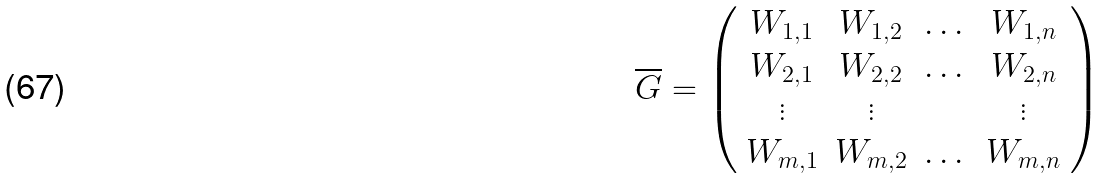Convert formula to latex. <formula><loc_0><loc_0><loc_500><loc_500>\overline { G } = \left ( \begin{array} { c c c c } W _ { 1 , 1 } & W _ { 1 , 2 } & \dots & W _ { 1 , n } \\ W _ { 2 , 1 } & W _ { 2 , 2 } & \dots & W _ { 2 , n } \\ \vdots & \vdots & & \vdots \\ W _ { m , 1 } & W _ { m , 2 } & \dots & W _ { m , n } \\ \end{array} \right )</formula> 